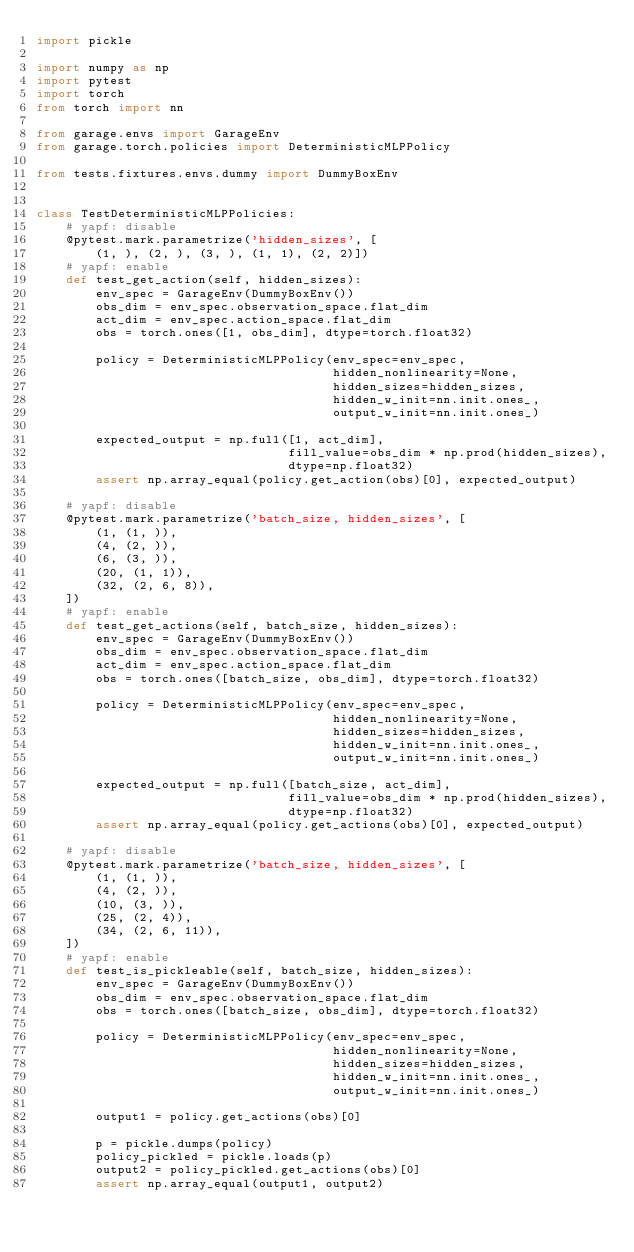<code> <loc_0><loc_0><loc_500><loc_500><_Python_>import pickle

import numpy as np
import pytest
import torch
from torch import nn

from garage.envs import GarageEnv
from garage.torch.policies import DeterministicMLPPolicy

from tests.fixtures.envs.dummy import DummyBoxEnv


class TestDeterministicMLPPolicies:
    # yapf: disable
    @pytest.mark.parametrize('hidden_sizes', [
        (1, ), (2, ), (3, ), (1, 1), (2, 2)])
    # yapf: enable
    def test_get_action(self, hidden_sizes):
        env_spec = GarageEnv(DummyBoxEnv())
        obs_dim = env_spec.observation_space.flat_dim
        act_dim = env_spec.action_space.flat_dim
        obs = torch.ones([1, obs_dim], dtype=torch.float32)

        policy = DeterministicMLPPolicy(env_spec=env_spec,
                                        hidden_nonlinearity=None,
                                        hidden_sizes=hidden_sizes,
                                        hidden_w_init=nn.init.ones_,
                                        output_w_init=nn.init.ones_)

        expected_output = np.full([1, act_dim],
                                  fill_value=obs_dim * np.prod(hidden_sizes),
                                  dtype=np.float32)
        assert np.array_equal(policy.get_action(obs)[0], expected_output)

    # yapf: disable
    @pytest.mark.parametrize('batch_size, hidden_sizes', [
        (1, (1, )),
        (4, (2, )),
        (6, (3, )),
        (20, (1, 1)),
        (32, (2, 6, 8)),
    ])
    # yapf: enable
    def test_get_actions(self, batch_size, hidden_sizes):
        env_spec = GarageEnv(DummyBoxEnv())
        obs_dim = env_spec.observation_space.flat_dim
        act_dim = env_spec.action_space.flat_dim
        obs = torch.ones([batch_size, obs_dim], dtype=torch.float32)

        policy = DeterministicMLPPolicy(env_spec=env_spec,
                                        hidden_nonlinearity=None,
                                        hidden_sizes=hidden_sizes,
                                        hidden_w_init=nn.init.ones_,
                                        output_w_init=nn.init.ones_)

        expected_output = np.full([batch_size, act_dim],
                                  fill_value=obs_dim * np.prod(hidden_sizes),
                                  dtype=np.float32)
        assert np.array_equal(policy.get_actions(obs)[0], expected_output)

    # yapf: disable
    @pytest.mark.parametrize('batch_size, hidden_sizes', [
        (1, (1, )),
        (4, (2, )),
        (10, (3, )),
        (25, (2, 4)),
        (34, (2, 6, 11)),
    ])
    # yapf: enable
    def test_is_pickleable(self, batch_size, hidden_sizes):
        env_spec = GarageEnv(DummyBoxEnv())
        obs_dim = env_spec.observation_space.flat_dim
        obs = torch.ones([batch_size, obs_dim], dtype=torch.float32)

        policy = DeterministicMLPPolicy(env_spec=env_spec,
                                        hidden_nonlinearity=None,
                                        hidden_sizes=hidden_sizes,
                                        hidden_w_init=nn.init.ones_,
                                        output_w_init=nn.init.ones_)

        output1 = policy.get_actions(obs)[0]

        p = pickle.dumps(policy)
        policy_pickled = pickle.loads(p)
        output2 = policy_pickled.get_actions(obs)[0]
        assert np.array_equal(output1, output2)
</code> 